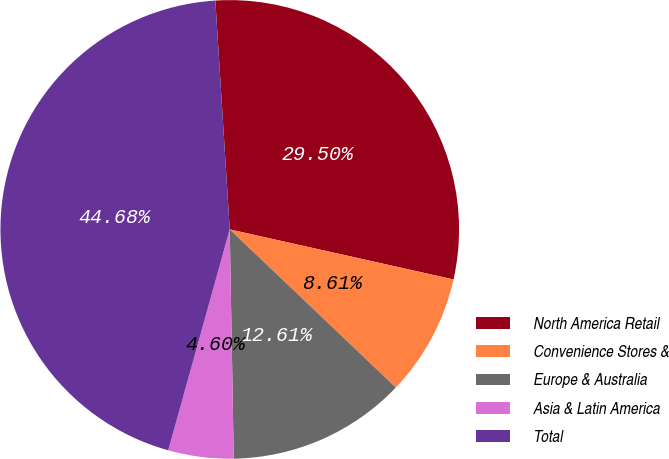Convert chart to OTSL. <chart><loc_0><loc_0><loc_500><loc_500><pie_chart><fcel>North America Retail<fcel>Convenience Stores &<fcel>Europe & Australia<fcel>Asia & Latin America<fcel>Total<nl><fcel>29.5%<fcel>8.61%<fcel>12.61%<fcel>4.6%<fcel>44.68%<nl></chart> 